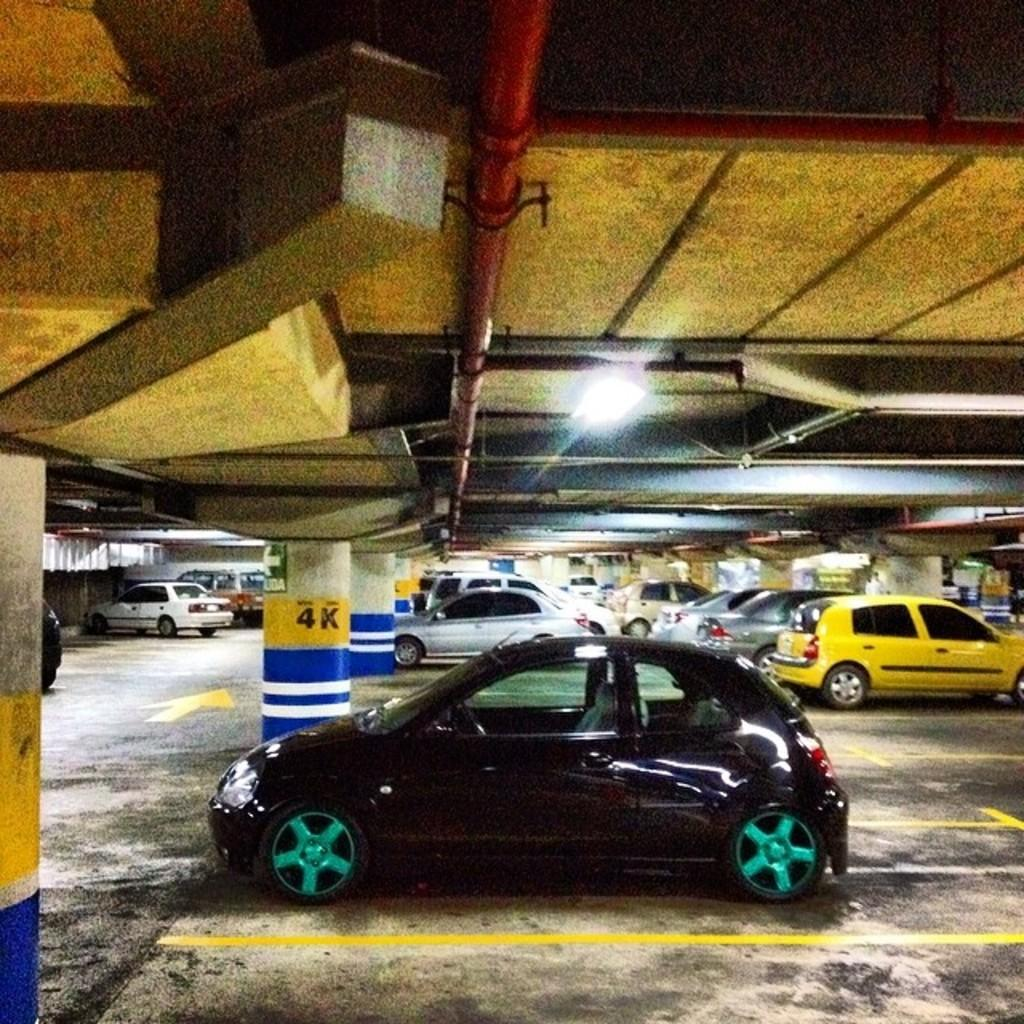<image>
Relay a brief, clear account of the picture shown. Parking garage with different cars that are parked on level 4K. 